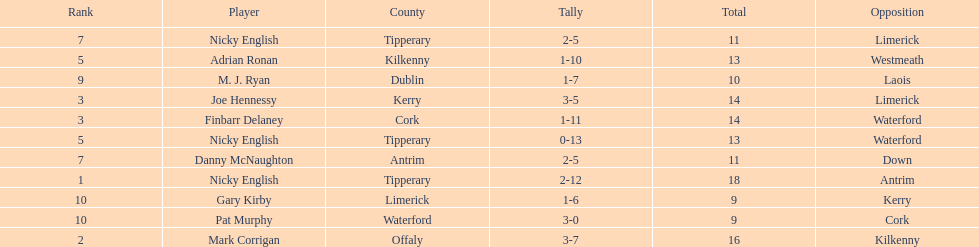Which player ranked the most? Nicky English. 